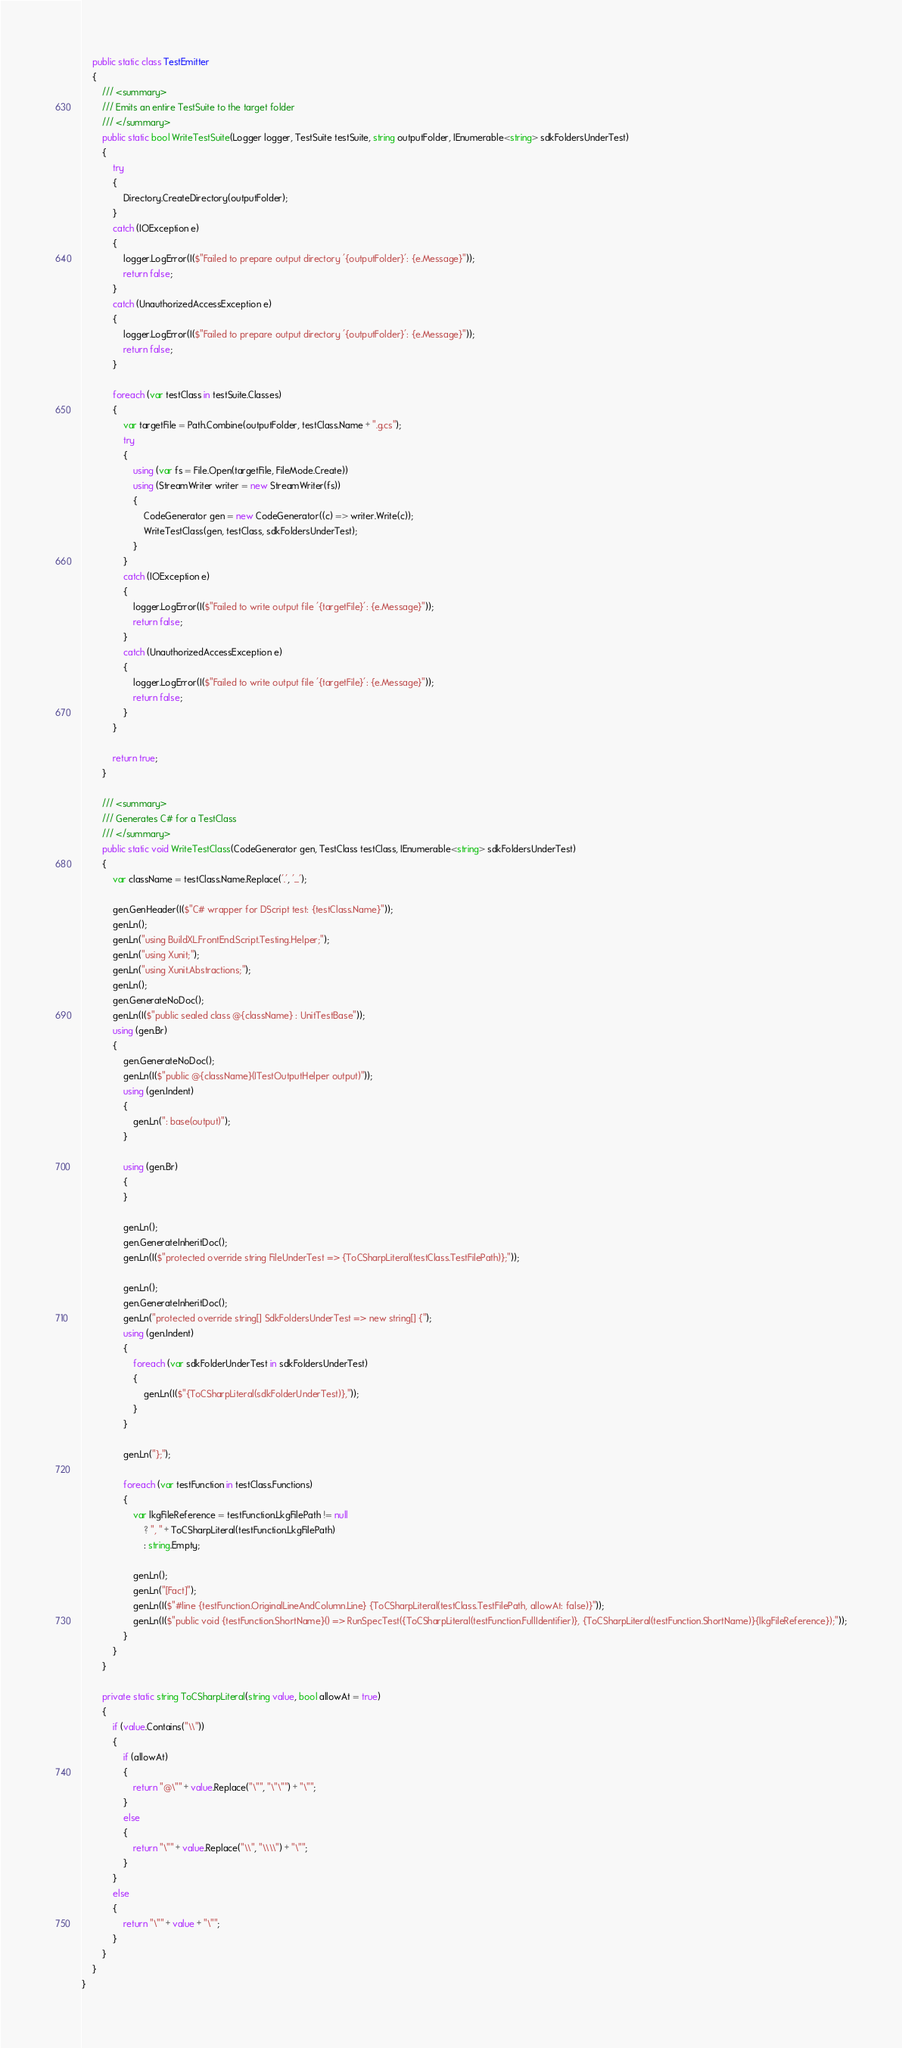Convert code to text. <code><loc_0><loc_0><loc_500><loc_500><_C#_>    public static class TestEmitter
    {
        /// <summary>
        /// Emits an entire TestSuite to the target folder
        /// </summary>
        public static bool WriteTestSuite(Logger logger, TestSuite testSuite, string outputFolder, IEnumerable<string> sdkFoldersUnderTest)
        {
            try
            {
                Directory.CreateDirectory(outputFolder);
            }
            catch (IOException e)
            {
                logger.LogError(I($"Failed to prepare output directory '{outputFolder}': {e.Message}"));
                return false;
            }
            catch (UnauthorizedAccessException e)
            {
                logger.LogError(I($"Failed to prepare output directory '{outputFolder}': {e.Message}"));
                return false;
            }

            foreach (var testClass in testSuite.Classes)
            {
                var targetFile = Path.Combine(outputFolder, testClass.Name + ".g.cs");
                try
                {
                    using (var fs = File.Open(targetFile, FileMode.Create))
                    using (StreamWriter writer = new StreamWriter(fs))
                    {
                        CodeGenerator gen = new CodeGenerator((c) => writer.Write(c));
                        WriteTestClass(gen, testClass, sdkFoldersUnderTest);
                    }
                }
                catch (IOException e)
                {
                    logger.LogError(I($"Failed to write output file '{targetFile}': {e.Message}"));
                    return false;
                }
                catch (UnauthorizedAccessException e)
                {
                    logger.LogError(I($"Failed to write output file '{targetFile}': {e.Message}"));
                    return false;
                }
            }

            return true;
        }

        /// <summary>
        /// Generates C# for a TestClass
        /// </summary>
        public static void WriteTestClass(CodeGenerator gen, TestClass testClass, IEnumerable<string> sdkFoldersUnderTest)
        {
            var className = testClass.Name.Replace('.', '_');

            gen.GenHeader(I($"C# wrapper for DScript test: {testClass.Name}"));
            gen.Ln();
            gen.Ln("using BuildXL.FrontEnd.Script.Testing.Helper;");
            gen.Ln("using Xunit;");
            gen.Ln("using Xunit.Abstractions;");
            gen.Ln();
            gen.GenerateNoDoc();
            gen.Ln(I($"public sealed class @{className} : UnitTestBase"));
            using (gen.Br)
            {
                gen.GenerateNoDoc();
                gen.Ln(I($"public @{className}(ITestOutputHelper output)"));
                using (gen.Indent)
                {
                    gen.Ln(": base(output)");
                }

                using (gen.Br)
                {
                }

                gen.Ln();
                gen.GenerateInheritDoc();
                gen.Ln(I($"protected override string FileUnderTest => {ToCSharpLiteral(testClass.TestFilePath)};"));

                gen.Ln();
                gen.GenerateInheritDoc();
                gen.Ln("protected override string[] SdkFoldersUnderTest => new string[] {");
                using (gen.Indent)
                {
                    foreach (var sdkFolderUnderTest in sdkFoldersUnderTest)
                    {
                        gen.Ln(I($"{ToCSharpLiteral(sdkFolderUnderTest)},"));
                    }
                }

                gen.Ln("};");

                foreach (var testFunction in testClass.Functions)
                {
                    var lkgFileReference = testFunction.LkgFilePath != null
                        ? ", " + ToCSharpLiteral(testFunction.LkgFilePath)
                        : string.Empty;

                    gen.Ln();
                    gen.Ln("[Fact]");
                    gen.Ln(I($"#line {testFunction.OriginalLineAndColumn.Line} {ToCSharpLiteral(testClass.TestFilePath, allowAt: false)}"));
                    gen.Ln(I($"public void {testFunction.ShortName}() => RunSpecTest({ToCSharpLiteral(testFunction.FullIdentifier)}, {ToCSharpLiteral(testFunction.ShortName)}{lkgFileReference});"));
                }
            }
        }

        private static string ToCSharpLiteral(string value, bool allowAt = true)
        {
            if (value.Contains("\\"))
            {
                if (allowAt)
                {
                    return "@\"" + value.Replace("\"", "\"\"") + "\"";
                }
                else
                {
                    return "\"" + value.Replace("\\", "\\\\") + "\"";
                }
            }
            else
            {
                return "\"" + value + "\"";
            }
        }
    }
}
</code> 